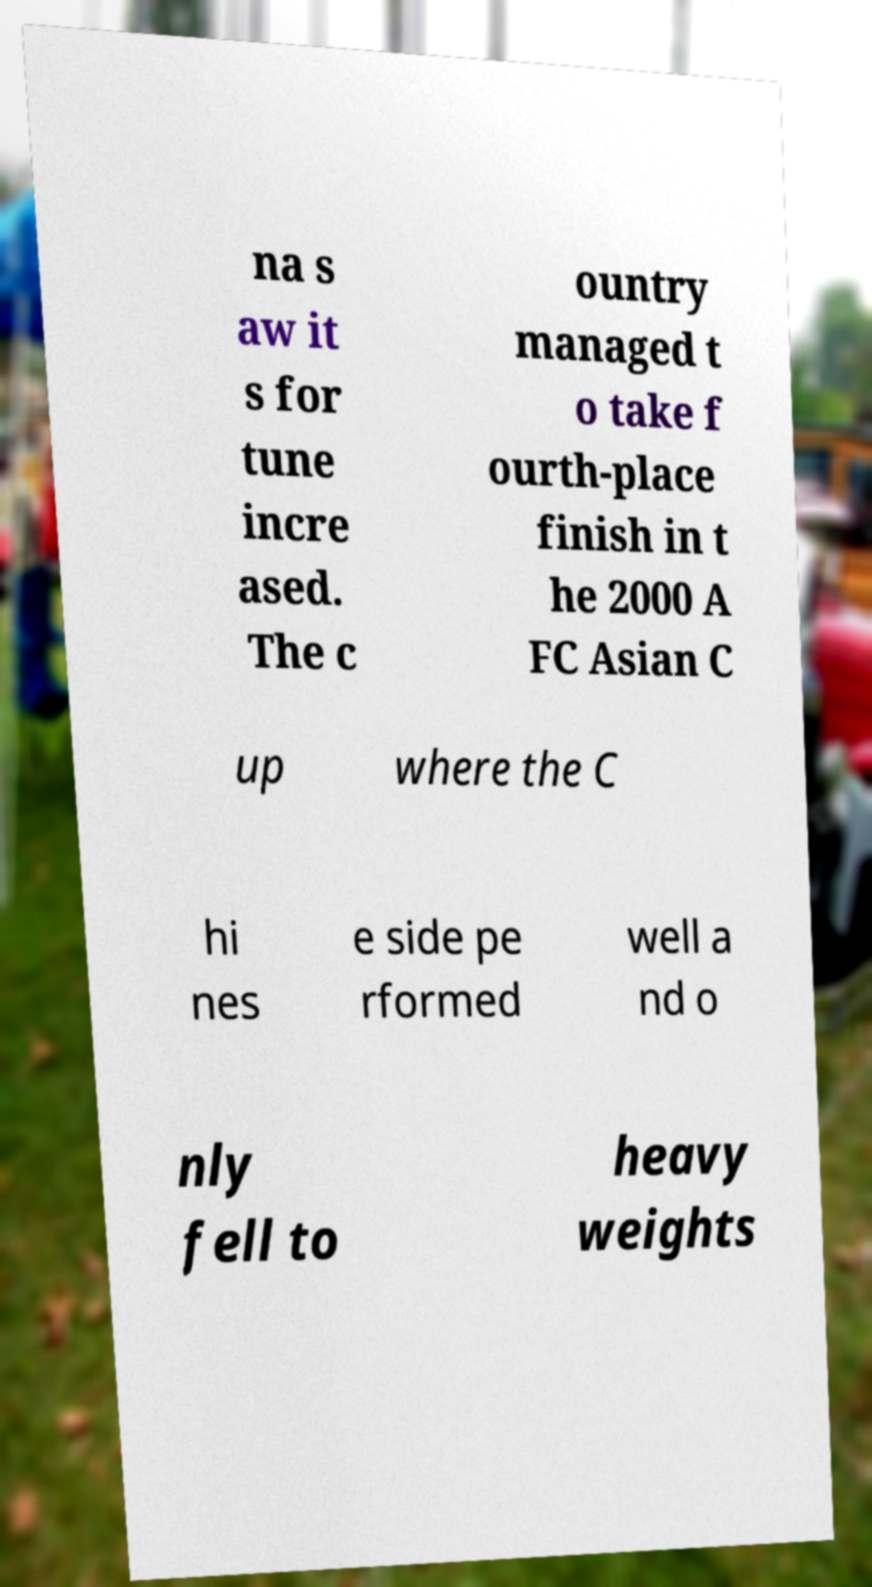I need the written content from this picture converted into text. Can you do that? na s aw it s for tune incre ased. The c ountry managed t o take f ourth-place finish in t he 2000 A FC Asian C up where the C hi nes e side pe rformed well a nd o nly fell to heavy weights 